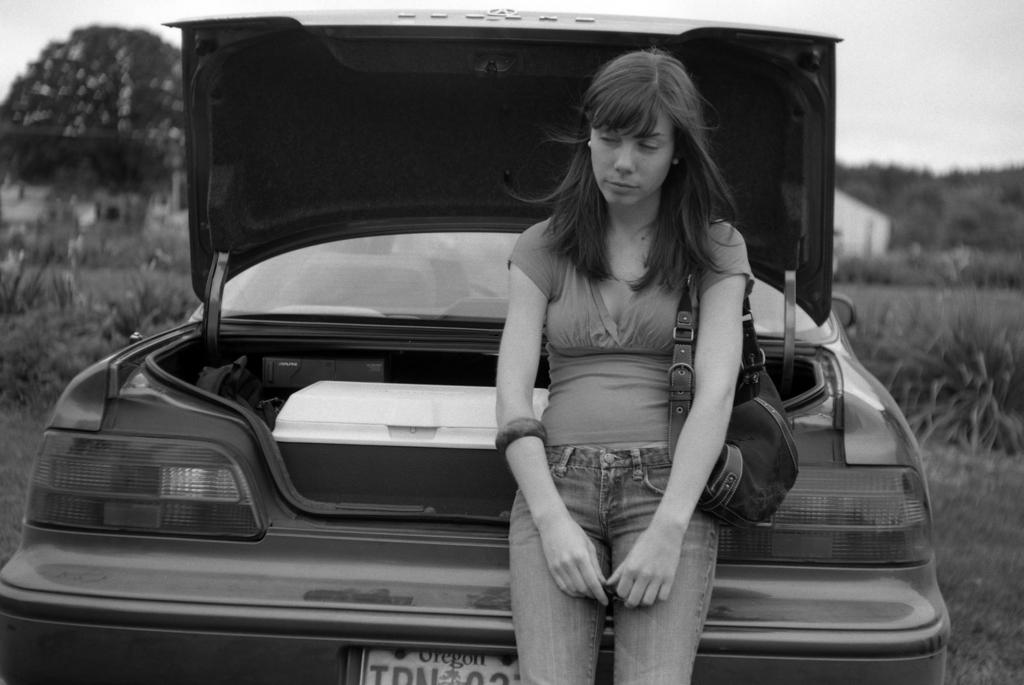What is the color scheme of the image? The image is black and white. What is the main subject in the middle of the image? There is a car and a person in the middle of the image. What type of vegetation is on the left side of the image? There are trees on the left side of the image. What is visible at the top of the image? The sky is visible at the top of the image. What type of war is depicted in the image? There is no war depicted in the image; it features a car, a person, trees, and the sky. Can you tell me how many donkeys are present in the image? There are no donkeys present in the image. 